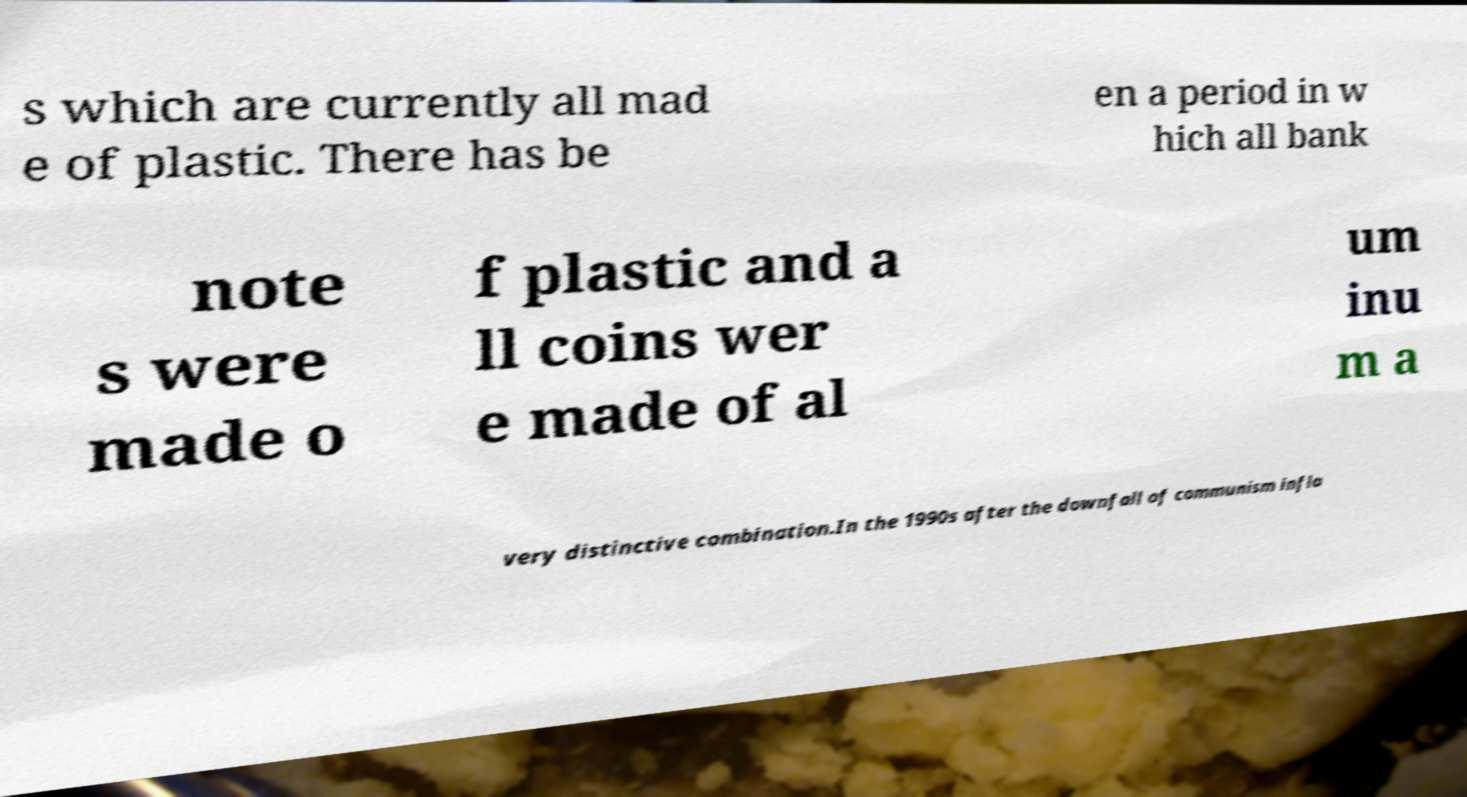Please identify and transcribe the text found in this image. s which are currently all mad e of plastic. There has be en a period in w hich all bank note s were made o f plastic and a ll coins wer e made of al um inu m a very distinctive combination.In the 1990s after the downfall of communism infla 